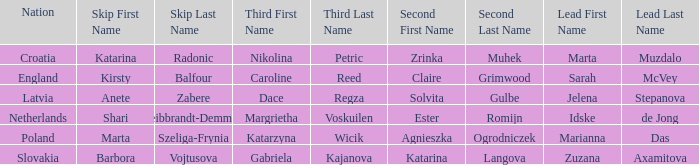What is the name of the third who has Barbora Vojtusova as Skip? Gabriela Kajanova. 